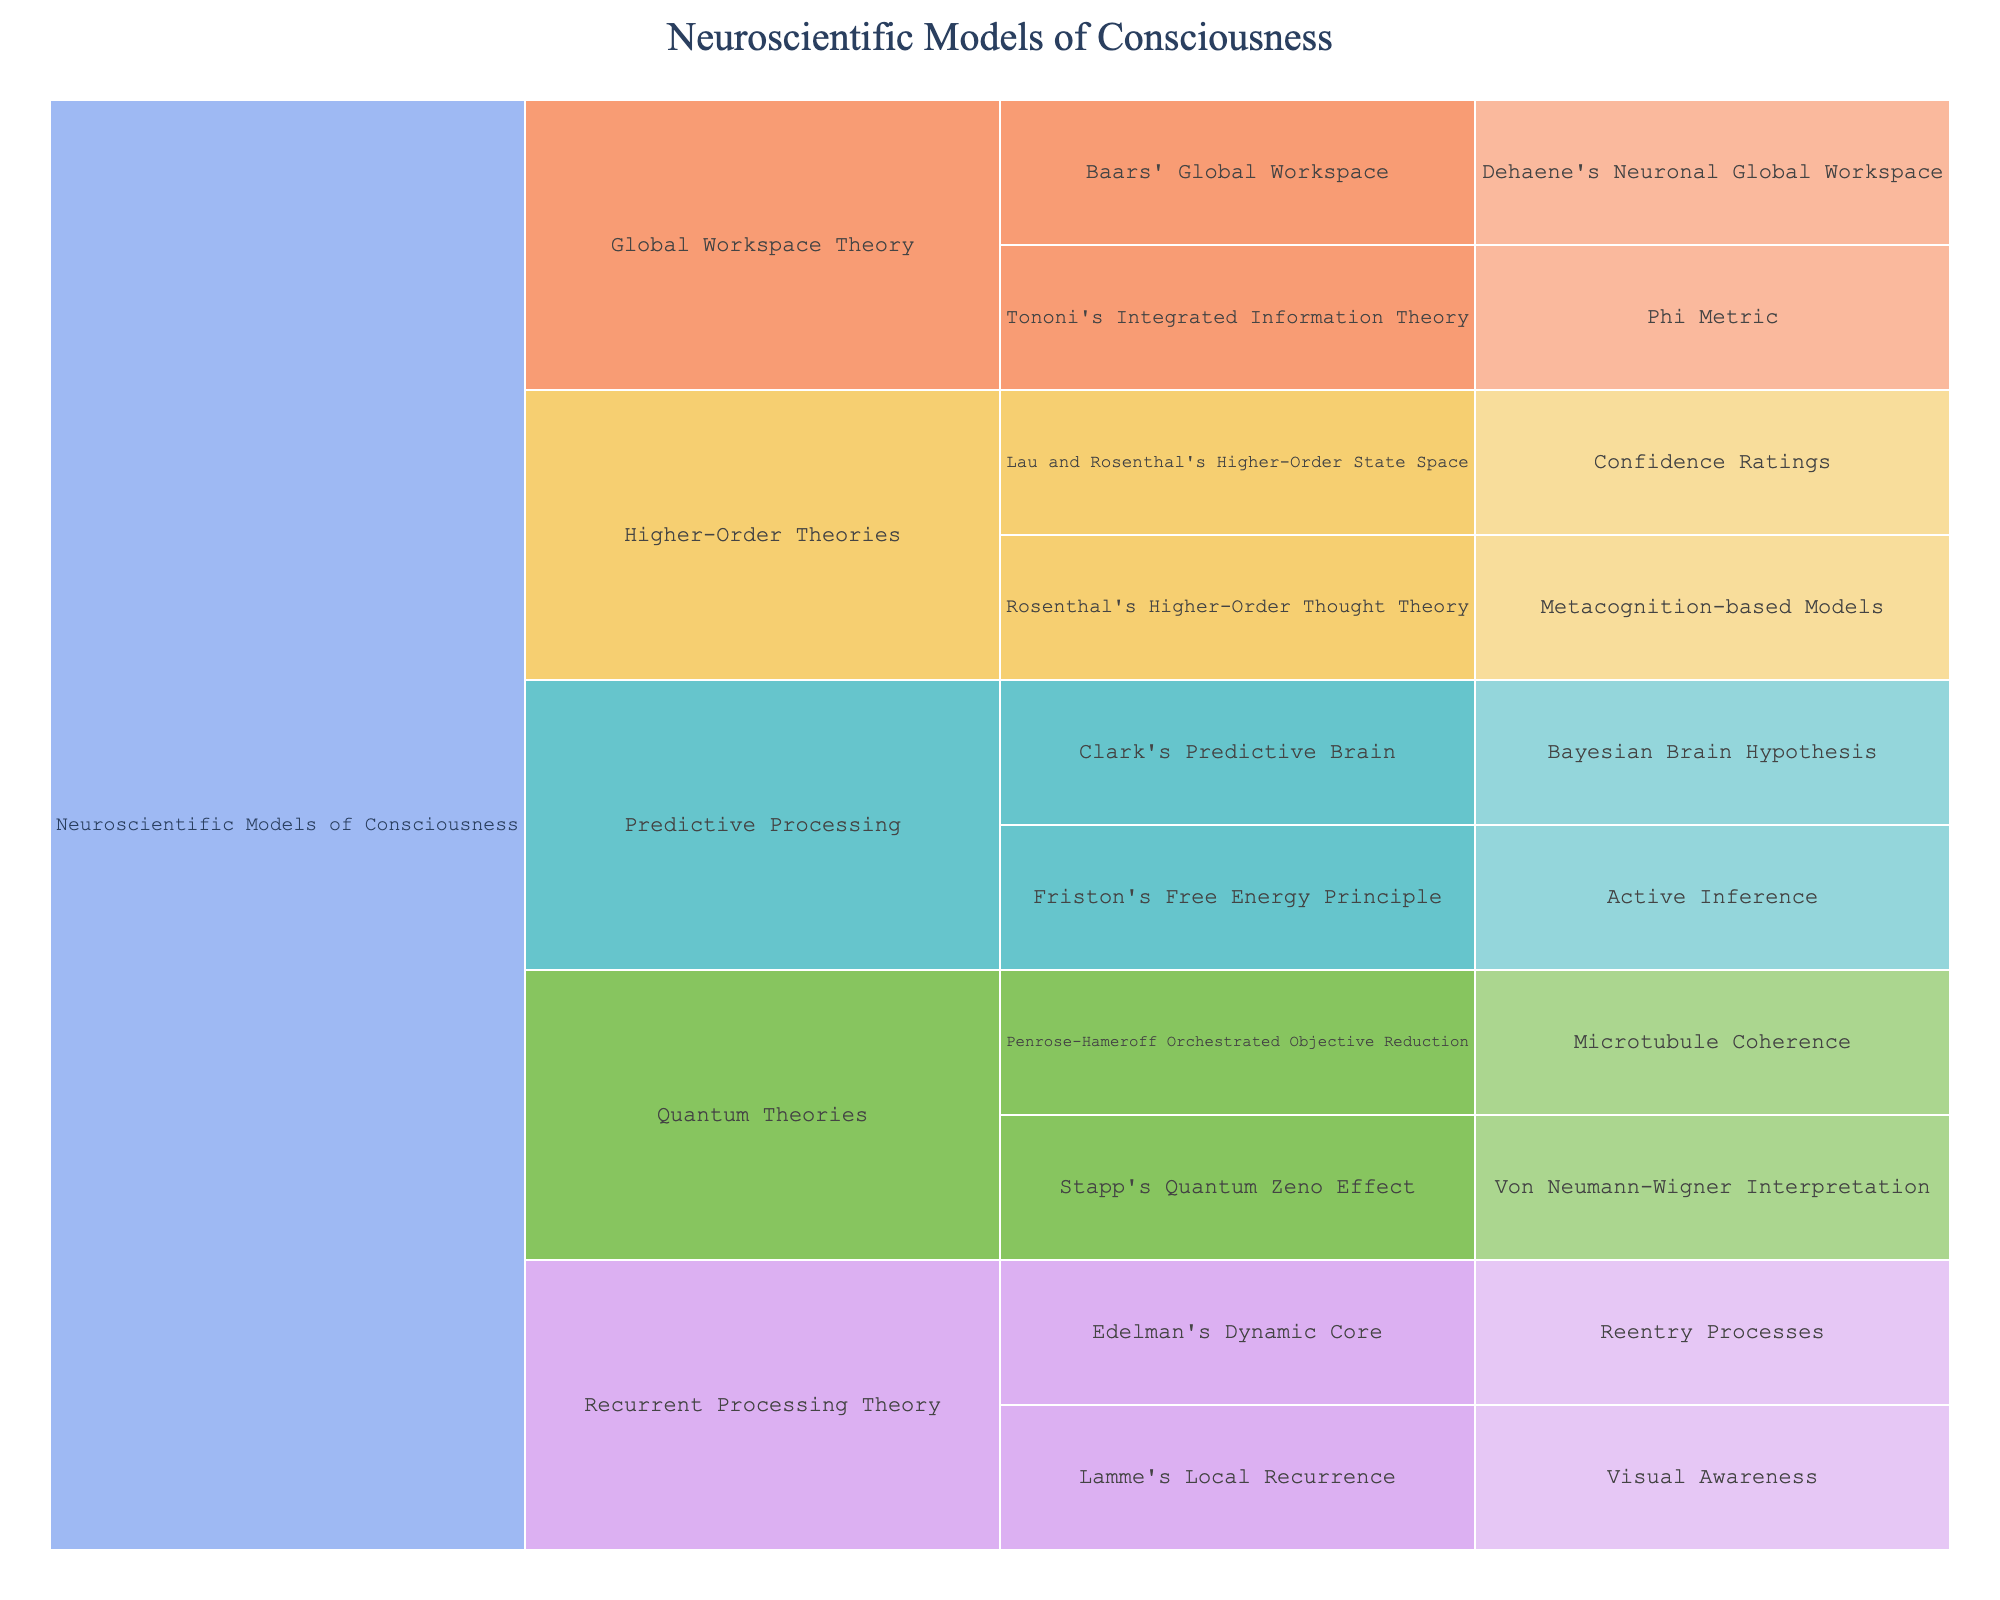How many primary categories are displayed in the Icicle Chart? The title mentions "Neuroscientific Models of Consciousness" as the root, and from there, the chart is divided into main categories. Counting these main branches from the root gives the total number of primary categories.
Answer: 4 Which theory has the most specific models listed in the chart? To determine this, look for the main categories and count the specific models under each. Compare the counts to identify the theory with the highest number of specific models.
Answer: Predictive Processing How many specific models are associated with the Global Workspace Theory? Find the branch labeled "Global Workspace Theory" and count the specific models that stem from it.
Answer: 3 Which category has both "Visual Awareness" and "Reentry Processes" as subcategories? Locate the subcategories "Visual Awareness" and "Reentry Processes" in the chart and trace them back to their common main category.
Answer: Recurrent Processing Theory Compare the number of specific models under "Higher-Order Theories" to those under "Quantum Theories". Which has more? Count the specific models under both "Higher-Order Theories" and "Quantum Theories". Compare these counts to see which category has more specific models.
Answer: Higher-Order Theories What is the total number of specific models listed in the entire chart? Sum the specific models listed under all subcategories across all main categories in the chart.
Answer: 10 Identify a subcategory that appears under "Predictive Processing" and describe its specific model. Locate the branch labeled "Predictive Processing" and identify one of its subcategories, then describe the corresponding specific model listed under it. For instance, "Clark's Predictive Brain".
Answer: Bayesian Brain Hypothesis Which theoretical framework includes the "Microtubule Coherence" model? Locate the "Microtubule Coherence" label in the chart and trace back up to its theoretical framework category.
Answer: Quantum Theories 